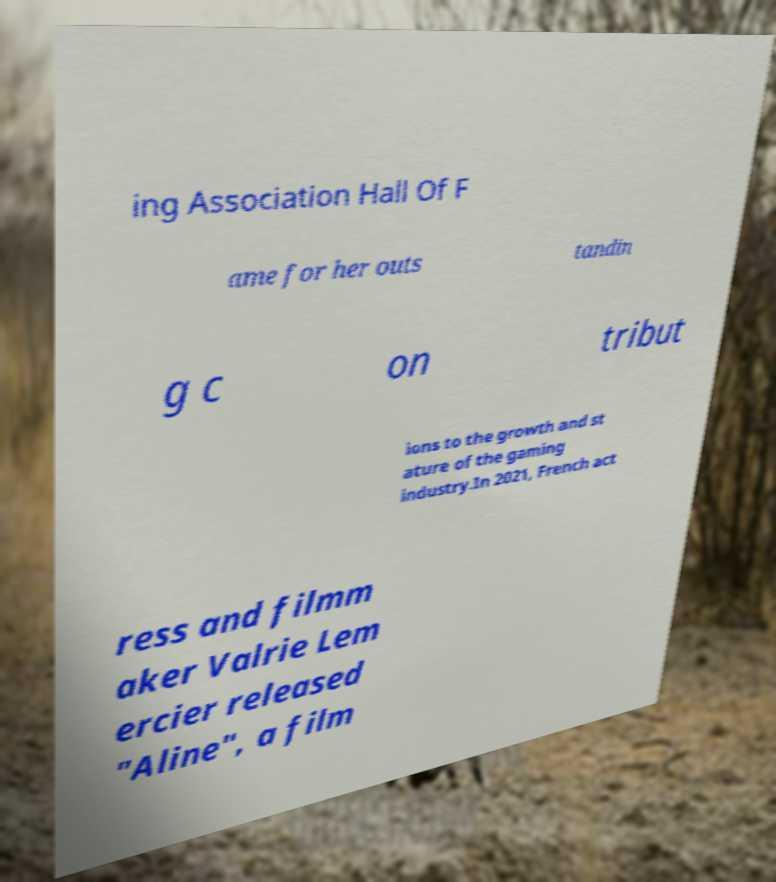Could you assist in decoding the text presented in this image and type it out clearly? ing Association Hall Of F ame for her outs tandin g c on tribut ions to the growth and st ature of the gaming industry.In 2021, French act ress and filmm aker Valrie Lem ercier released "Aline", a film 